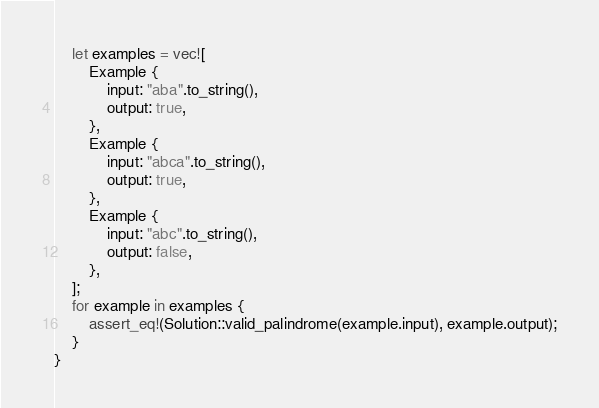Convert code to text. <code><loc_0><loc_0><loc_500><loc_500><_Rust_>    let examples = vec![
        Example {
            input: "aba".to_string(),
            output: true,
        },
        Example {
            input: "abca".to_string(),
            output: true,
        },
        Example {
            input: "abc".to_string(),
            output: false,
        },
    ];
    for example in examples {
        assert_eq!(Solution::valid_palindrome(example.input), example.output);
    }
}
</code> 